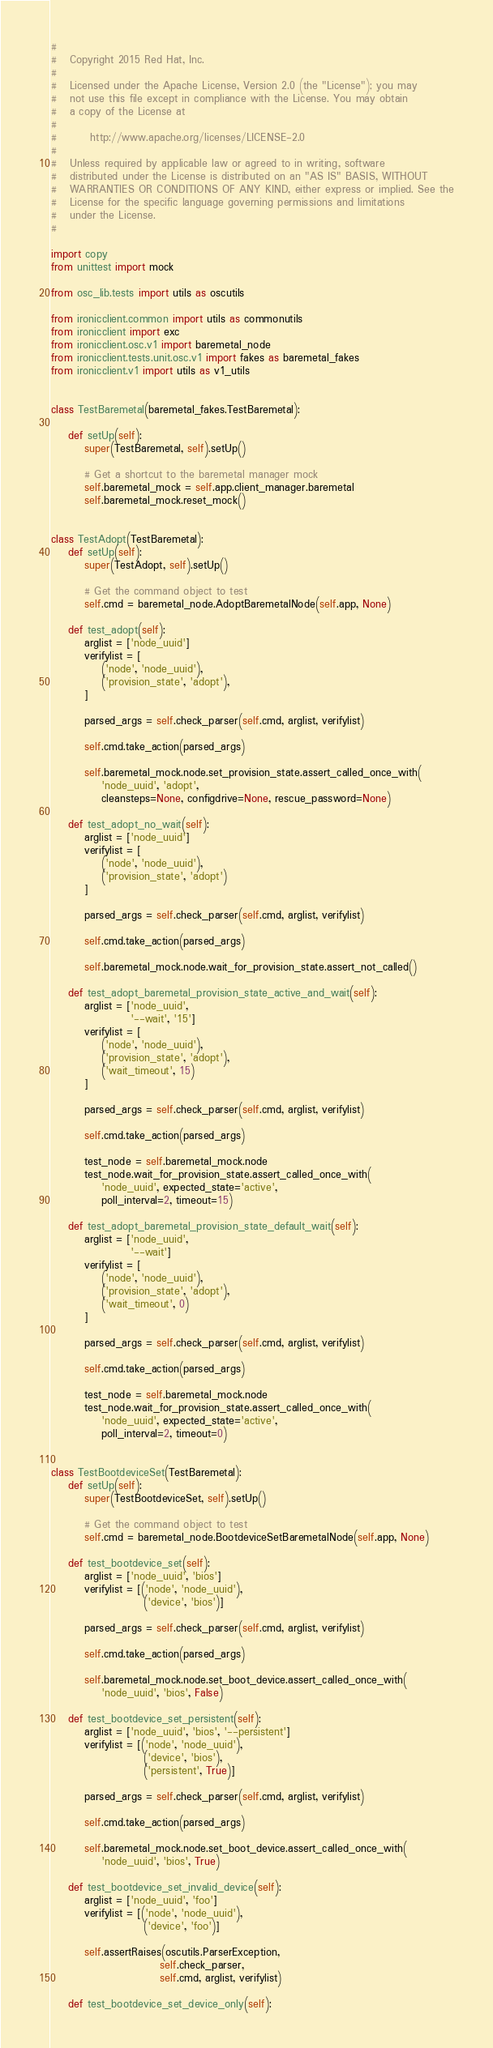<code> <loc_0><loc_0><loc_500><loc_500><_Python_>#
#   Copyright 2015 Red Hat, Inc.
#
#   Licensed under the Apache License, Version 2.0 (the "License"); you may
#   not use this file except in compliance with the License. You may obtain
#   a copy of the License at
#
#        http://www.apache.org/licenses/LICENSE-2.0
#
#   Unless required by applicable law or agreed to in writing, software
#   distributed under the License is distributed on an "AS IS" BASIS, WITHOUT
#   WARRANTIES OR CONDITIONS OF ANY KIND, either express or implied. See the
#   License for the specific language governing permissions and limitations
#   under the License.
#

import copy
from unittest import mock

from osc_lib.tests import utils as oscutils

from ironicclient.common import utils as commonutils
from ironicclient import exc
from ironicclient.osc.v1 import baremetal_node
from ironicclient.tests.unit.osc.v1 import fakes as baremetal_fakes
from ironicclient.v1 import utils as v1_utils


class TestBaremetal(baremetal_fakes.TestBaremetal):

    def setUp(self):
        super(TestBaremetal, self).setUp()

        # Get a shortcut to the baremetal manager mock
        self.baremetal_mock = self.app.client_manager.baremetal
        self.baremetal_mock.reset_mock()


class TestAdopt(TestBaremetal):
    def setUp(self):
        super(TestAdopt, self).setUp()

        # Get the command object to test
        self.cmd = baremetal_node.AdoptBaremetalNode(self.app, None)

    def test_adopt(self):
        arglist = ['node_uuid']
        verifylist = [
            ('node', 'node_uuid'),
            ('provision_state', 'adopt'),
        ]

        parsed_args = self.check_parser(self.cmd, arglist, verifylist)

        self.cmd.take_action(parsed_args)

        self.baremetal_mock.node.set_provision_state.assert_called_once_with(
            'node_uuid', 'adopt',
            cleansteps=None, configdrive=None, rescue_password=None)

    def test_adopt_no_wait(self):
        arglist = ['node_uuid']
        verifylist = [
            ('node', 'node_uuid'),
            ('provision_state', 'adopt')
        ]

        parsed_args = self.check_parser(self.cmd, arglist, verifylist)

        self.cmd.take_action(parsed_args)

        self.baremetal_mock.node.wait_for_provision_state.assert_not_called()

    def test_adopt_baremetal_provision_state_active_and_wait(self):
        arglist = ['node_uuid',
                   '--wait', '15']
        verifylist = [
            ('node', 'node_uuid'),
            ('provision_state', 'adopt'),
            ('wait_timeout', 15)
        ]

        parsed_args = self.check_parser(self.cmd, arglist, verifylist)

        self.cmd.take_action(parsed_args)

        test_node = self.baremetal_mock.node
        test_node.wait_for_provision_state.assert_called_once_with(
            'node_uuid', expected_state='active',
            poll_interval=2, timeout=15)

    def test_adopt_baremetal_provision_state_default_wait(self):
        arglist = ['node_uuid',
                   '--wait']
        verifylist = [
            ('node', 'node_uuid'),
            ('provision_state', 'adopt'),
            ('wait_timeout', 0)
        ]

        parsed_args = self.check_parser(self.cmd, arglist, verifylist)

        self.cmd.take_action(parsed_args)

        test_node = self.baremetal_mock.node
        test_node.wait_for_provision_state.assert_called_once_with(
            'node_uuid', expected_state='active',
            poll_interval=2, timeout=0)


class TestBootdeviceSet(TestBaremetal):
    def setUp(self):
        super(TestBootdeviceSet, self).setUp()

        # Get the command object to test
        self.cmd = baremetal_node.BootdeviceSetBaremetalNode(self.app, None)

    def test_bootdevice_set(self):
        arglist = ['node_uuid', 'bios']
        verifylist = [('node', 'node_uuid'),
                      ('device', 'bios')]

        parsed_args = self.check_parser(self.cmd, arglist, verifylist)

        self.cmd.take_action(parsed_args)

        self.baremetal_mock.node.set_boot_device.assert_called_once_with(
            'node_uuid', 'bios', False)

    def test_bootdevice_set_persistent(self):
        arglist = ['node_uuid', 'bios', '--persistent']
        verifylist = [('node', 'node_uuid'),
                      ('device', 'bios'),
                      ('persistent', True)]

        parsed_args = self.check_parser(self.cmd, arglist, verifylist)

        self.cmd.take_action(parsed_args)

        self.baremetal_mock.node.set_boot_device.assert_called_once_with(
            'node_uuid', 'bios', True)

    def test_bootdevice_set_invalid_device(self):
        arglist = ['node_uuid', 'foo']
        verifylist = [('node', 'node_uuid'),
                      ('device', 'foo')]

        self.assertRaises(oscutils.ParserException,
                          self.check_parser,
                          self.cmd, arglist, verifylist)

    def test_bootdevice_set_device_only(self):</code> 